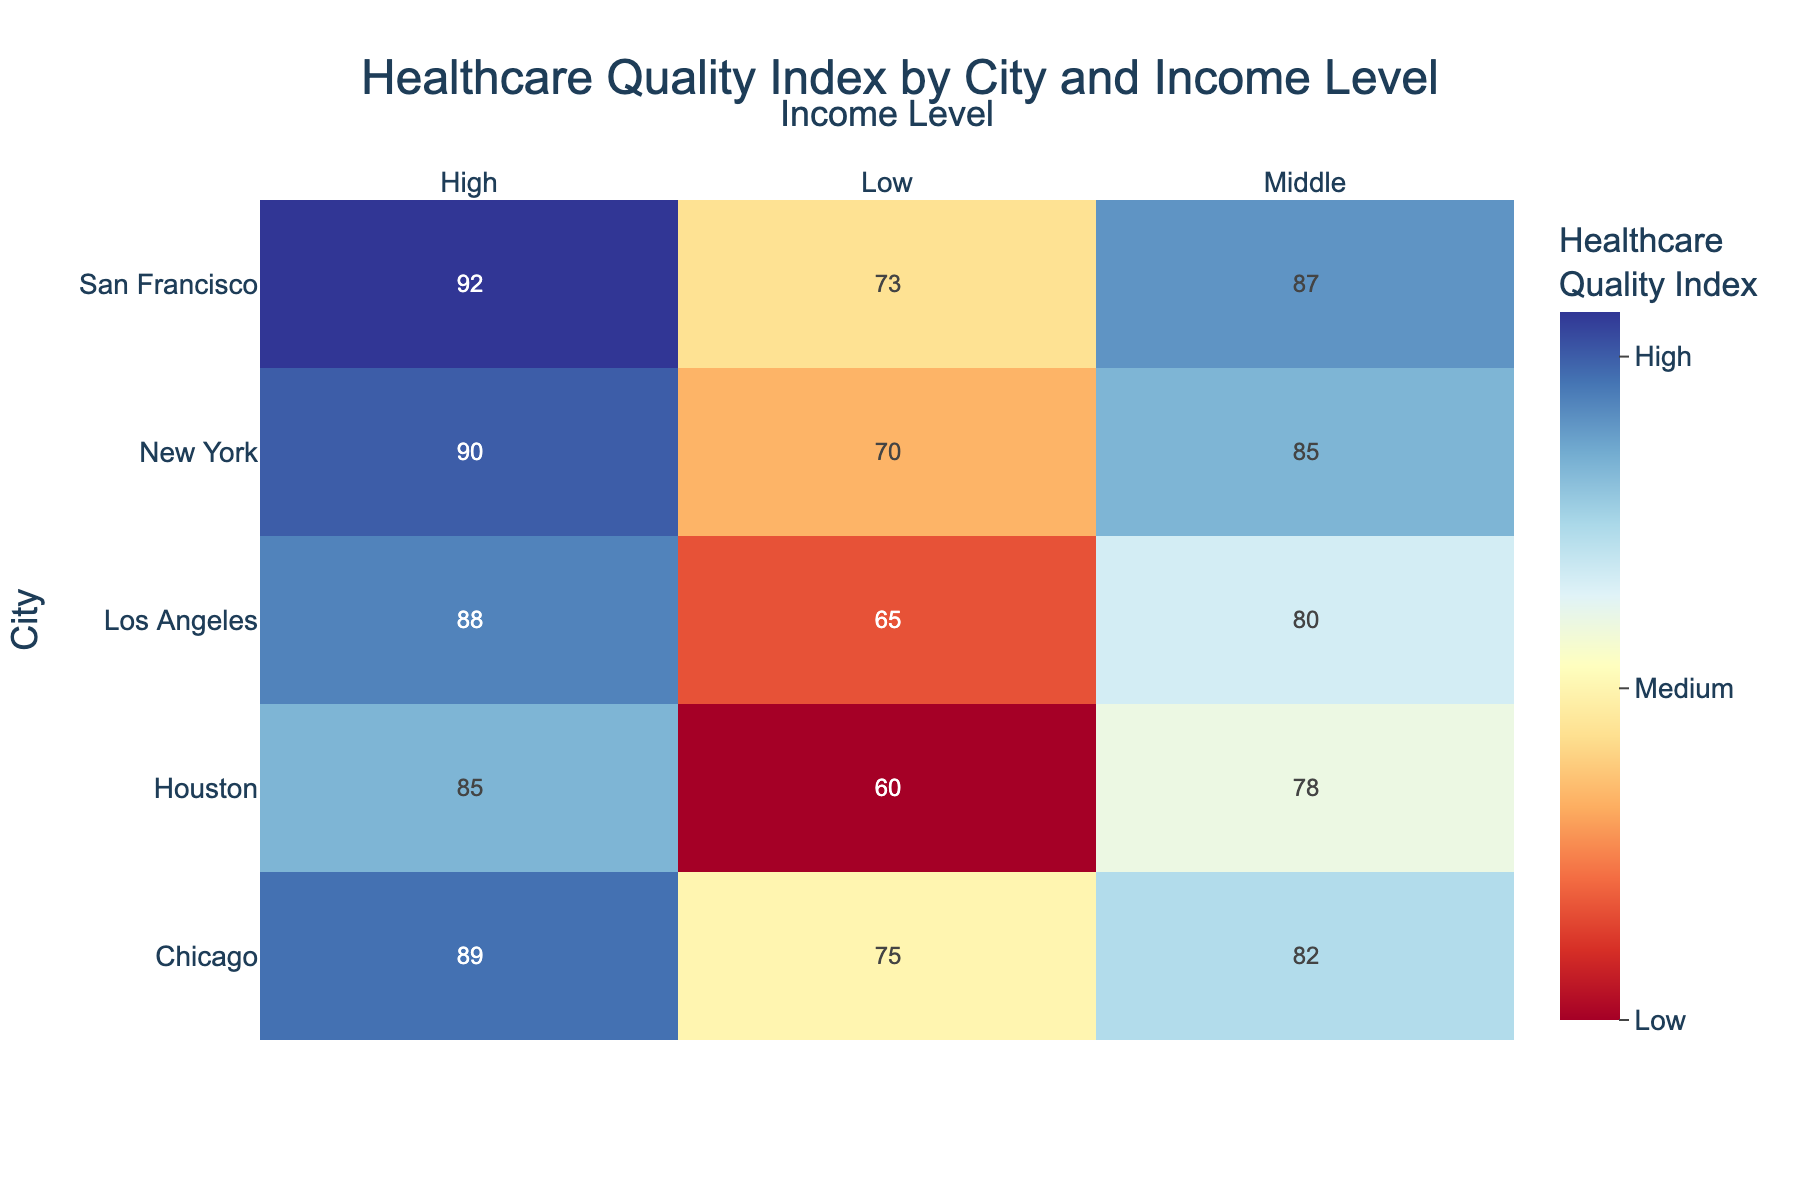What's the title of the figure? The title is displayed at the top of the figure. It reads "Healthcare Quality Index by City and Income Level"
Answer: Healthcare Quality Index by City and Income Level Which city has the highest Healthcare Quality Index for the high-income level? Look at the cells corresponding to the high-income level (right column) for each city. Identify the cell with the highest value. San Francisco has the highest value of 92.
Answer: San Francisco What is the Healthcare Quality Index for middle-income groups in Los Angeles? Locate Los Angeles on the y-axis and then follow across to the middle-income column to find the Healthcare Quality Index value. The value is 80.
Answer: 80 Which city has the lowest Healthcare Quality Index for the low-income level? Focus on the left column for low-income groups. Identify the lowest value among the cities listed. Houston has the lowest value of 60.
Answer: Houston What are the Healthcare Quality Index values for high-income groups across all cities? Look at the rightmost column for high-income groups and read the values for all cities: New York (90), Los Angeles (88), Chicago (89), Houston (85), and San Francisco (92).
Answer: 90, 88, 89, 85, 92 How does the Healthcare Quality Index for middle-income groups compare between New York and Houston? Find and compare the values for New York and Houston in the middle-income column. New York has a value of 85, while Houston has a value of 78. New York is higher.
Answer: New York is higher What is the range of Healthcare Quality Index values for San Francisco across all income levels? Identify the values for San Francisco across all columns: low-income (73), middle-income (87), and high-income (92). Calculate the range as the difference between the highest and lowest values: 92 - 73.
Answer: 19 Which income level generally shows the highest Healthcare Quality Index across cities? Compare the values in each income level column across different cities. The high-income level generally has the highest values compared to low and middle-income levels.
Answer: High-income level Is there a city where middle-income groups have a higher Healthcare Quality Index than high-income groups? Examine all cities and compare middle-income and high-income values. No city has a higher value for middle-income groups than high-income groups.
Answer: No Is the Healthcare Quality Index for low-income groups in Chicago higher or lower than that in New York? Compare the values for low-income groups between Chicago (75) and New York (70). Chicago's value is higher.
Answer: Higher 